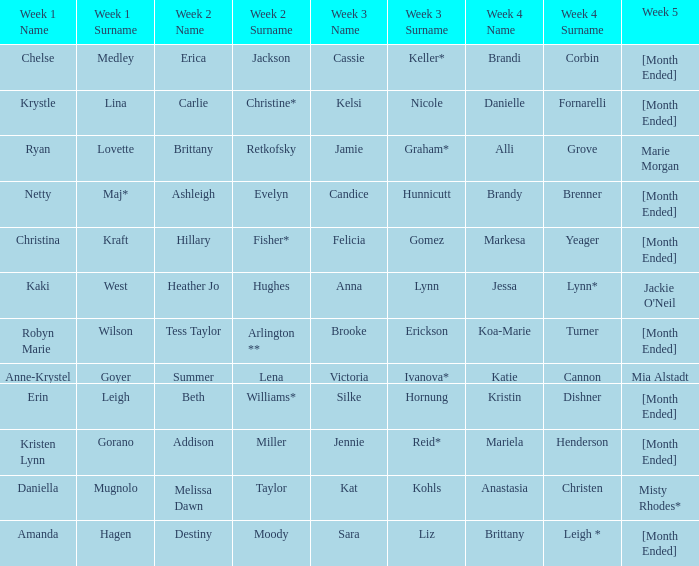What is the week 1 with candice hunnicutt in week 3? Netty Maj*. 